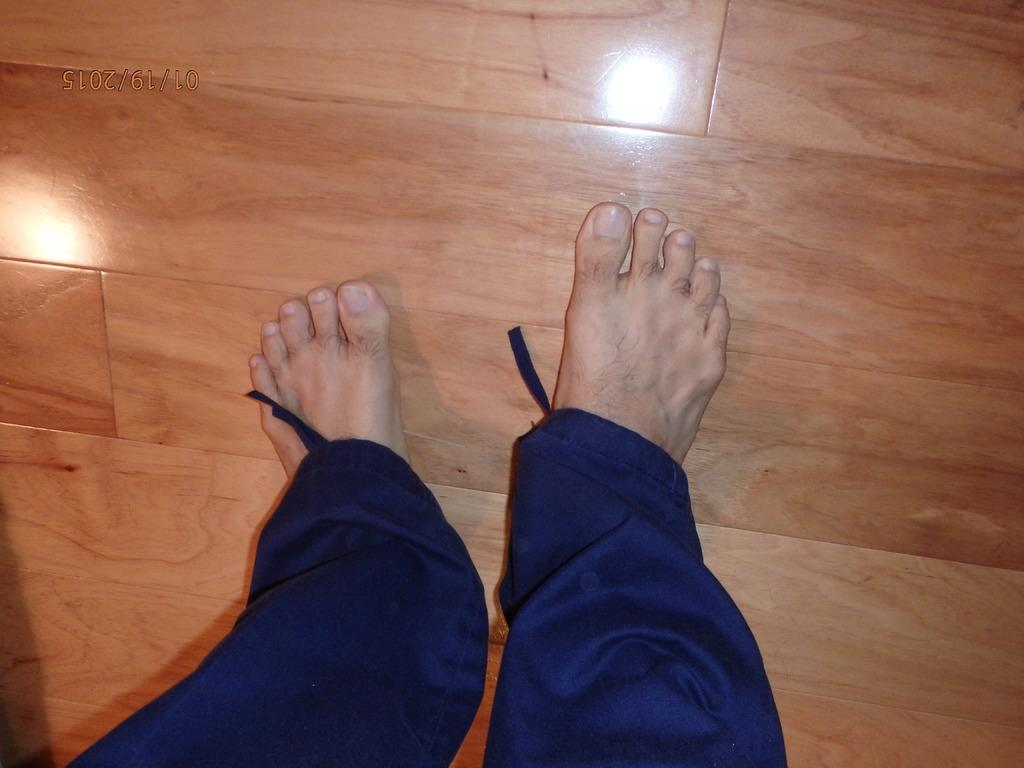What part of a person's body can be seen in the image? There are a person's legs visible in the image. Where are the legs located in relation to the floor? The legs are on the floor. Is there any additional information or marking on the image? Yes, there is a watermark in the image. What type of butter is being used to slip on the floor in the image? There is no butter or slipping depicted in the image; it only shows a person's legs on the floor. Is there a doll present in the image? No, there is no doll present in the image. 